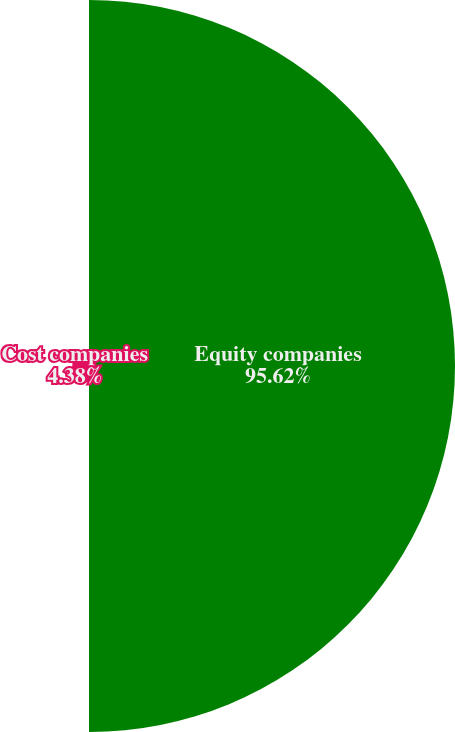<chart> <loc_0><loc_0><loc_500><loc_500><pie_chart><fcel>Equity companies<fcel>Cost companies<nl><fcel>95.62%<fcel>4.38%<nl></chart> 